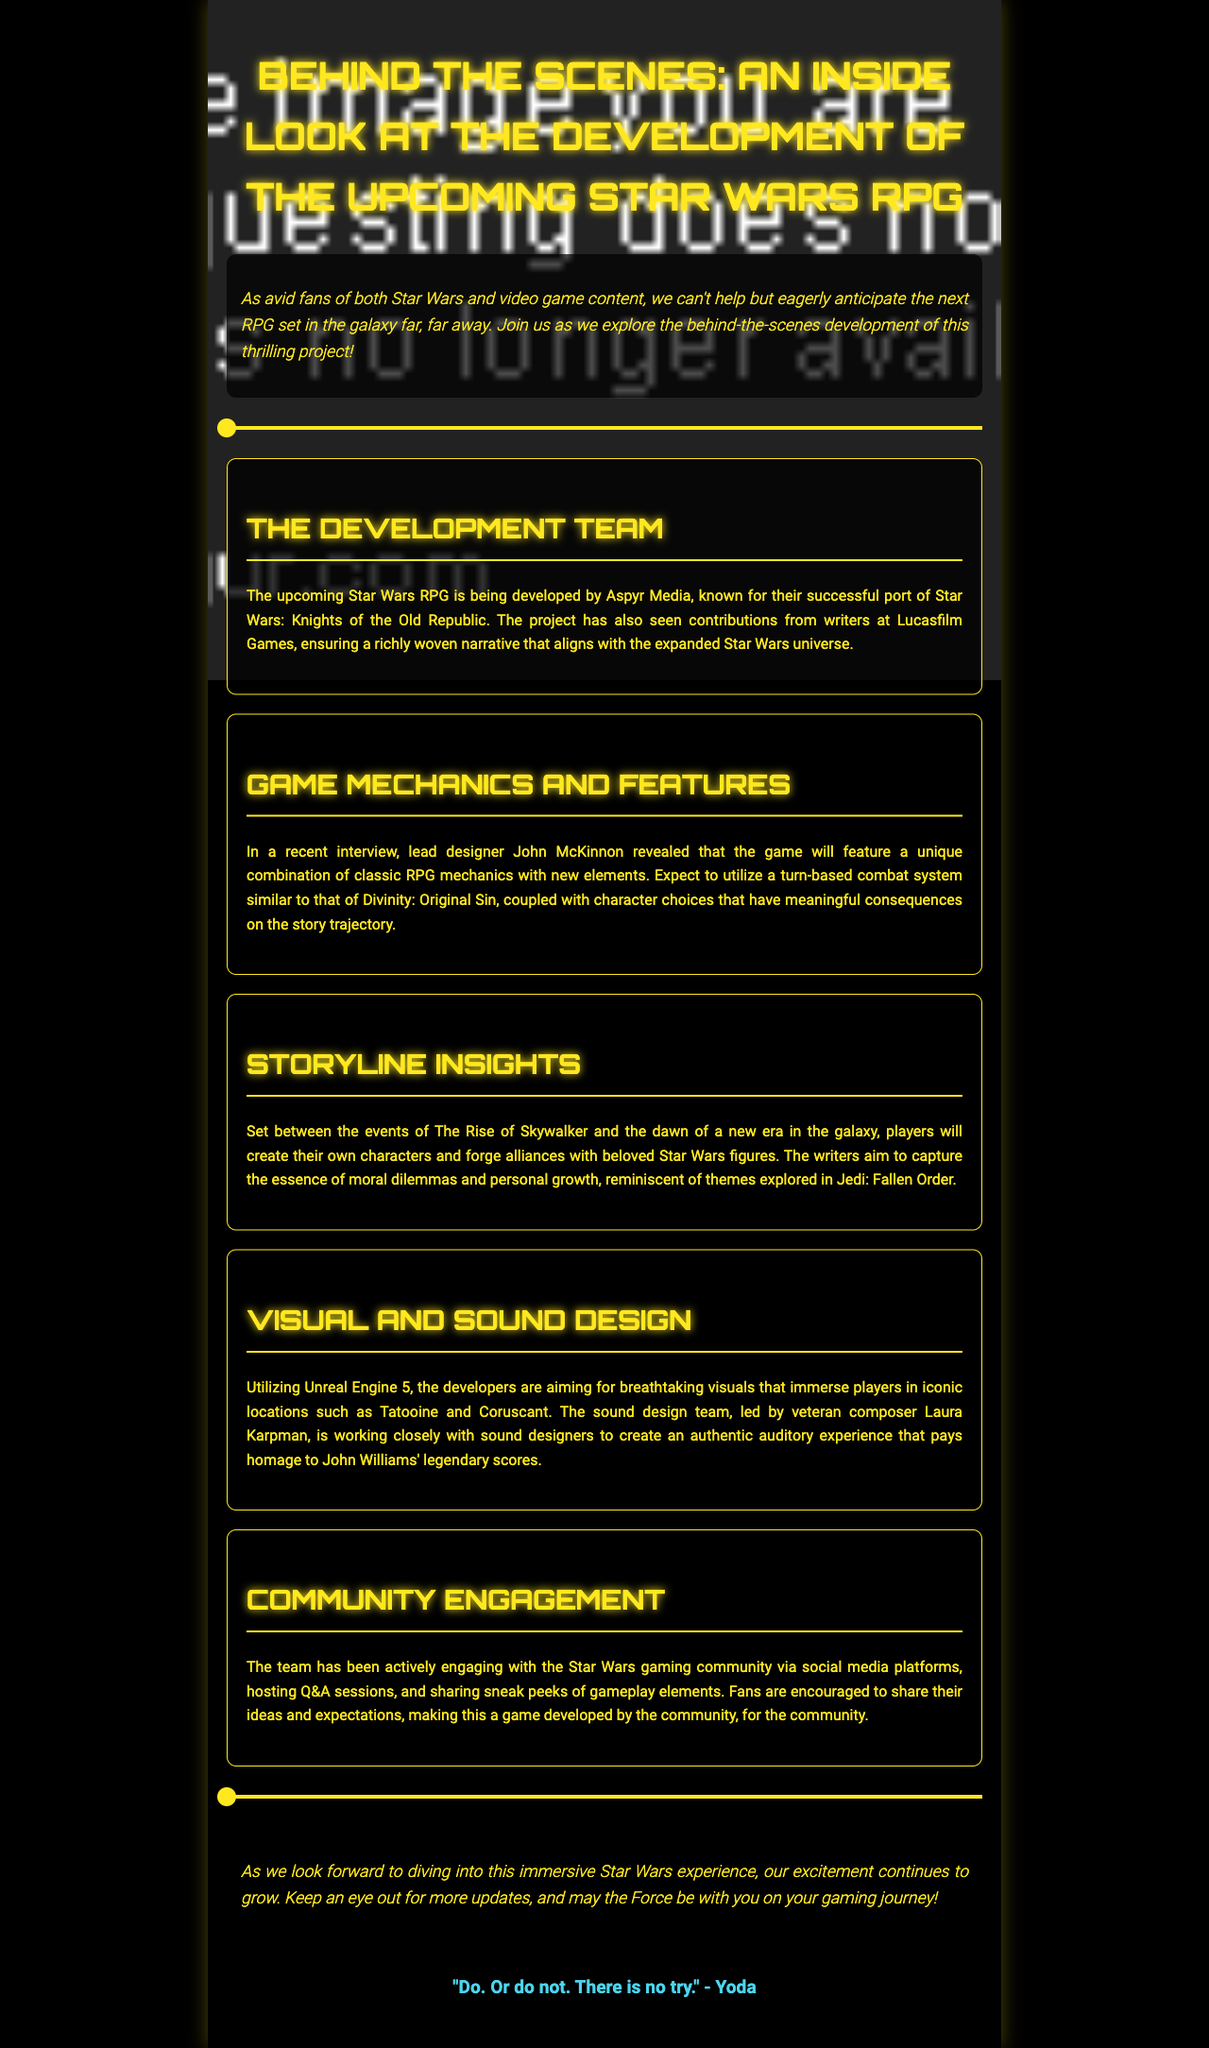What is the name of the development team for the Star Wars RPG? The development team for the upcoming Star Wars RPG is Aspyr Media, known for their successful port of Star Wars: Knights of the Old Republic.
Answer: Aspyr Media What game mechanics will the RPG feature? The RPG will feature a unique combination of classic RPG mechanics and new elements, including a turn-based combat system.
Answer: Turn-based combat system Who is leading the sound design for the game? The sound design team is led by veteran composer Laura Karpman, who is working closely with sound designers.
Answer: Laura Karpman What period does the game's storyline take place in? The storyline is set between the events of The Rise of Skywalker and the dawn of a new era in the galaxy.
Answer: Between The Rise of Skywalker and dawn of a new era How is the development team engaging with the community? The team has been actively engaging with the Star Wars gaming community via social media platforms, hosting Q&A sessions, and sharing sneak peeks.
Answer: Social media platforms What themes will the game explore? The writers aim to capture the essence of moral dilemmas and personal growth, similar to themes explored in Jedi: Fallen Order.
Answer: Moral dilemmas and personal growth What engine is used for the game's visuals? The developers are utilizing Unreal Engine 5 for breathtaking visuals in the game.
Answer: Unreal Engine 5 What type of newsletter is this document categorized as? The document is categorized as a newsletter about the development of the Star Wars RPG.
Answer: Newsletter 